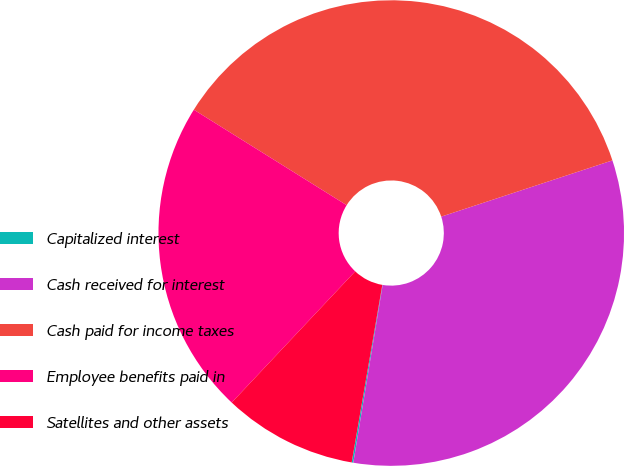<chart> <loc_0><loc_0><loc_500><loc_500><pie_chart><fcel>Capitalized interest<fcel>Cash received for interest<fcel>Cash paid for income taxes<fcel>Employee benefits paid in<fcel>Satellites and other assets<nl><fcel>0.11%<fcel>32.66%<fcel>36.06%<fcel>21.87%<fcel>9.3%<nl></chart> 